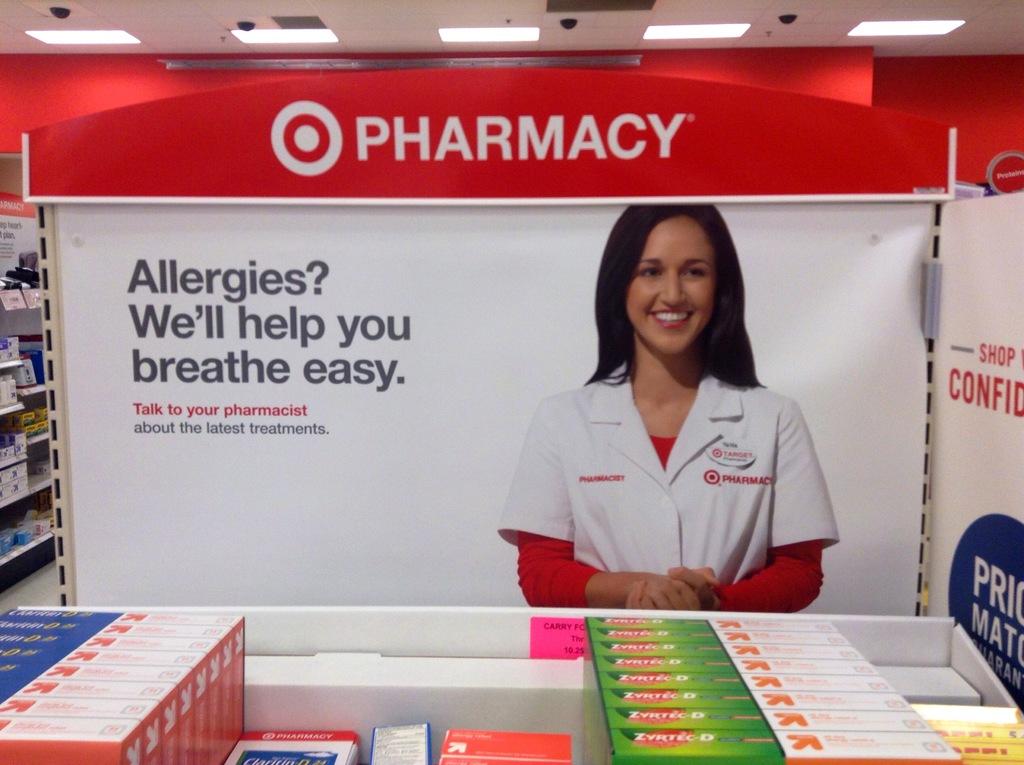What ailment are they advertising to help with?
Your answer should be very brief. Allergies. 